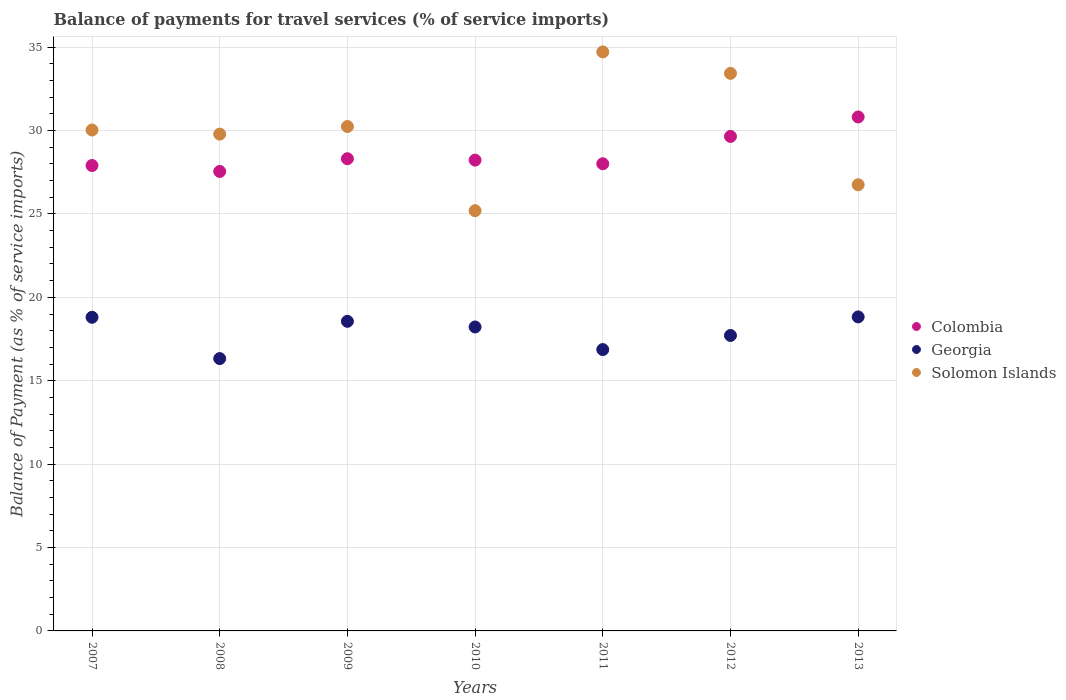How many different coloured dotlines are there?
Give a very brief answer. 3. What is the balance of payments for travel services in Colombia in 2009?
Make the answer very short. 28.31. Across all years, what is the maximum balance of payments for travel services in Colombia?
Ensure brevity in your answer.  30.82. Across all years, what is the minimum balance of payments for travel services in Colombia?
Ensure brevity in your answer.  27.55. In which year was the balance of payments for travel services in Solomon Islands minimum?
Make the answer very short. 2010. What is the total balance of payments for travel services in Georgia in the graph?
Provide a succinct answer. 125.33. What is the difference between the balance of payments for travel services in Georgia in 2011 and that in 2012?
Offer a terse response. -0.85. What is the difference between the balance of payments for travel services in Solomon Islands in 2007 and the balance of payments for travel services in Georgia in 2009?
Your response must be concise. 11.47. What is the average balance of payments for travel services in Colombia per year?
Give a very brief answer. 28.64. In the year 2010, what is the difference between the balance of payments for travel services in Colombia and balance of payments for travel services in Solomon Islands?
Your answer should be compact. 3.03. In how many years, is the balance of payments for travel services in Solomon Islands greater than 6 %?
Your response must be concise. 7. What is the ratio of the balance of payments for travel services in Solomon Islands in 2008 to that in 2010?
Your answer should be very brief. 1.18. Is the difference between the balance of payments for travel services in Colombia in 2008 and 2010 greater than the difference between the balance of payments for travel services in Solomon Islands in 2008 and 2010?
Keep it short and to the point. No. What is the difference between the highest and the second highest balance of payments for travel services in Solomon Islands?
Your answer should be compact. 1.29. What is the difference between the highest and the lowest balance of payments for travel services in Solomon Islands?
Provide a short and direct response. 9.52. Is the sum of the balance of payments for travel services in Georgia in 2009 and 2011 greater than the maximum balance of payments for travel services in Colombia across all years?
Your response must be concise. Yes. Is the balance of payments for travel services in Colombia strictly greater than the balance of payments for travel services in Georgia over the years?
Keep it short and to the point. Yes. Is the balance of payments for travel services in Georgia strictly less than the balance of payments for travel services in Solomon Islands over the years?
Ensure brevity in your answer.  Yes. Does the graph contain any zero values?
Your answer should be compact. No. What is the title of the graph?
Provide a succinct answer. Balance of payments for travel services (% of service imports). Does "Samoa" appear as one of the legend labels in the graph?
Offer a very short reply. No. What is the label or title of the Y-axis?
Keep it short and to the point. Balance of Payment (as % of service imports). What is the Balance of Payment (as % of service imports) in Colombia in 2007?
Keep it short and to the point. 27.91. What is the Balance of Payment (as % of service imports) of Georgia in 2007?
Offer a very short reply. 18.8. What is the Balance of Payment (as % of service imports) in Solomon Islands in 2007?
Provide a succinct answer. 30.03. What is the Balance of Payment (as % of service imports) of Colombia in 2008?
Make the answer very short. 27.55. What is the Balance of Payment (as % of service imports) of Georgia in 2008?
Your response must be concise. 16.33. What is the Balance of Payment (as % of service imports) of Solomon Islands in 2008?
Provide a short and direct response. 29.79. What is the Balance of Payment (as % of service imports) of Colombia in 2009?
Offer a terse response. 28.31. What is the Balance of Payment (as % of service imports) of Georgia in 2009?
Make the answer very short. 18.56. What is the Balance of Payment (as % of service imports) in Solomon Islands in 2009?
Make the answer very short. 30.24. What is the Balance of Payment (as % of service imports) of Colombia in 2010?
Your answer should be very brief. 28.23. What is the Balance of Payment (as % of service imports) of Georgia in 2010?
Your answer should be very brief. 18.22. What is the Balance of Payment (as % of service imports) in Solomon Islands in 2010?
Ensure brevity in your answer.  25.2. What is the Balance of Payment (as % of service imports) of Colombia in 2011?
Keep it short and to the point. 28.01. What is the Balance of Payment (as % of service imports) of Georgia in 2011?
Your response must be concise. 16.87. What is the Balance of Payment (as % of service imports) of Solomon Islands in 2011?
Offer a very short reply. 34.72. What is the Balance of Payment (as % of service imports) of Colombia in 2012?
Make the answer very short. 29.65. What is the Balance of Payment (as % of service imports) in Georgia in 2012?
Offer a very short reply. 17.71. What is the Balance of Payment (as % of service imports) of Solomon Islands in 2012?
Ensure brevity in your answer.  33.43. What is the Balance of Payment (as % of service imports) in Colombia in 2013?
Provide a succinct answer. 30.82. What is the Balance of Payment (as % of service imports) of Georgia in 2013?
Keep it short and to the point. 18.83. What is the Balance of Payment (as % of service imports) in Solomon Islands in 2013?
Keep it short and to the point. 26.75. Across all years, what is the maximum Balance of Payment (as % of service imports) in Colombia?
Make the answer very short. 30.82. Across all years, what is the maximum Balance of Payment (as % of service imports) of Georgia?
Provide a succinct answer. 18.83. Across all years, what is the maximum Balance of Payment (as % of service imports) in Solomon Islands?
Give a very brief answer. 34.72. Across all years, what is the minimum Balance of Payment (as % of service imports) of Colombia?
Your answer should be very brief. 27.55. Across all years, what is the minimum Balance of Payment (as % of service imports) of Georgia?
Provide a succinct answer. 16.33. Across all years, what is the minimum Balance of Payment (as % of service imports) of Solomon Islands?
Make the answer very short. 25.2. What is the total Balance of Payment (as % of service imports) of Colombia in the graph?
Offer a terse response. 200.47. What is the total Balance of Payment (as % of service imports) in Georgia in the graph?
Provide a short and direct response. 125.33. What is the total Balance of Payment (as % of service imports) of Solomon Islands in the graph?
Your answer should be very brief. 210.16. What is the difference between the Balance of Payment (as % of service imports) in Colombia in 2007 and that in 2008?
Your response must be concise. 0.36. What is the difference between the Balance of Payment (as % of service imports) of Georgia in 2007 and that in 2008?
Your answer should be very brief. 2.48. What is the difference between the Balance of Payment (as % of service imports) of Solomon Islands in 2007 and that in 2008?
Ensure brevity in your answer.  0.25. What is the difference between the Balance of Payment (as % of service imports) in Colombia in 2007 and that in 2009?
Provide a succinct answer. -0.41. What is the difference between the Balance of Payment (as % of service imports) in Georgia in 2007 and that in 2009?
Ensure brevity in your answer.  0.24. What is the difference between the Balance of Payment (as % of service imports) of Solomon Islands in 2007 and that in 2009?
Make the answer very short. -0.21. What is the difference between the Balance of Payment (as % of service imports) in Colombia in 2007 and that in 2010?
Keep it short and to the point. -0.32. What is the difference between the Balance of Payment (as % of service imports) of Georgia in 2007 and that in 2010?
Your answer should be very brief. 0.58. What is the difference between the Balance of Payment (as % of service imports) of Solomon Islands in 2007 and that in 2010?
Keep it short and to the point. 4.84. What is the difference between the Balance of Payment (as % of service imports) in Colombia in 2007 and that in 2011?
Give a very brief answer. -0.11. What is the difference between the Balance of Payment (as % of service imports) of Georgia in 2007 and that in 2011?
Offer a terse response. 1.94. What is the difference between the Balance of Payment (as % of service imports) in Solomon Islands in 2007 and that in 2011?
Provide a short and direct response. -4.68. What is the difference between the Balance of Payment (as % of service imports) of Colombia in 2007 and that in 2012?
Your response must be concise. -1.74. What is the difference between the Balance of Payment (as % of service imports) of Georgia in 2007 and that in 2012?
Ensure brevity in your answer.  1.09. What is the difference between the Balance of Payment (as % of service imports) of Solomon Islands in 2007 and that in 2012?
Ensure brevity in your answer.  -3.4. What is the difference between the Balance of Payment (as % of service imports) in Colombia in 2007 and that in 2013?
Offer a terse response. -2.91. What is the difference between the Balance of Payment (as % of service imports) in Georgia in 2007 and that in 2013?
Provide a short and direct response. -0.02. What is the difference between the Balance of Payment (as % of service imports) of Solomon Islands in 2007 and that in 2013?
Give a very brief answer. 3.28. What is the difference between the Balance of Payment (as % of service imports) of Colombia in 2008 and that in 2009?
Provide a short and direct response. -0.76. What is the difference between the Balance of Payment (as % of service imports) in Georgia in 2008 and that in 2009?
Provide a short and direct response. -2.23. What is the difference between the Balance of Payment (as % of service imports) of Solomon Islands in 2008 and that in 2009?
Your answer should be very brief. -0.46. What is the difference between the Balance of Payment (as % of service imports) of Colombia in 2008 and that in 2010?
Your answer should be compact. -0.68. What is the difference between the Balance of Payment (as % of service imports) in Georgia in 2008 and that in 2010?
Make the answer very short. -1.89. What is the difference between the Balance of Payment (as % of service imports) of Solomon Islands in 2008 and that in 2010?
Your answer should be compact. 4.59. What is the difference between the Balance of Payment (as % of service imports) in Colombia in 2008 and that in 2011?
Ensure brevity in your answer.  -0.46. What is the difference between the Balance of Payment (as % of service imports) of Georgia in 2008 and that in 2011?
Your answer should be very brief. -0.54. What is the difference between the Balance of Payment (as % of service imports) in Solomon Islands in 2008 and that in 2011?
Ensure brevity in your answer.  -4.93. What is the difference between the Balance of Payment (as % of service imports) of Colombia in 2008 and that in 2012?
Provide a succinct answer. -2.1. What is the difference between the Balance of Payment (as % of service imports) of Georgia in 2008 and that in 2012?
Offer a very short reply. -1.39. What is the difference between the Balance of Payment (as % of service imports) of Solomon Islands in 2008 and that in 2012?
Give a very brief answer. -3.64. What is the difference between the Balance of Payment (as % of service imports) of Colombia in 2008 and that in 2013?
Ensure brevity in your answer.  -3.27. What is the difference between the Balance of Payment (as % of service imports) in Georgia in 2008 and that in 2013?
Make the answer very short. -2.5. What is the difference between the Balance of Payment (as % of service imports) of Solomon Islands in 2008 and that in 2013?
Your response must be concise. 3.04. What is the difference between the Balance of Payment (as % of service imports) of Colombia in 2009 and that in 2010?
Give a very brief answer. 0.08. What is the difference between the Balance of Payment (as % of service imports) of Georgia in 2009 and that in 2010?
Keep it short and to the point. 0.34. What is the difference between the Balance of Payment (as % of service imports) of Solomon Islands in 2009 and that in 2010?
Give a very brief answer. 5.05. What is the difference between the Balance of Payment (as % of service imports) in Colombia in 2009 and that in 2011?
Keep it short and to the point. 0.3. What is the difference between the Balance of Payment (as % of service imports) of Georgia in 2009 and that in 2011?
Offer a very short reply. 1.69. What is the difference between the Balance of Payment (as % of service imports) in Solomon Islands in 2009 and that in 2011?
Make the answer very short. -4.47. What is the difference between the Balance of Payment (as % of service imports) of Colombia in 2009 and that in 2012?
Ensure brevity in your answer.  -1.34. What is the difference between the Balance of Payment (as % of service imports) in Georgia in 2009 and that in 2012?
Give a very brief answer. 0.85. What is the difference between the Balance of Payment (as % of service imports) in Solomon Islands in 2009 and that in 2012?
Offer a terse response. -3.19. What is the difference between the Balance of Payment (as % of service imports) in Colombia in 2009 and that in 2013?
Provide a succinct answer. -2.5. What is the difference between the Balance of Payment (as % of service imports) in Georgia in 2009 and that in 2013?
Give a very brief answer. -0.26. What is the difference between the Balance of Payment (as % of service imports) in Solomon Islands in 2009 and that in 2013?
Your answer should be compact. 3.49. What is the difference between the Balance of Payment (as % of service imports) in Colombia in 2010 and that in 2011?
Keep it short and to the point. 0.22. What is the difference between the Balance of Payment (as % of service imports) of Georgia in 2010 and that in 2011?
Offer a very short reply. 1.35. What is the difference between the Balance of Payment (as % of service imports) of Solomon Islands in 2010 and that in 2011?
Make the answer very short. -9.52. What is the difference between the Balance of Payment (as % of service imports) in Colombia in 2010 and that in 2012?
Keep it short and to the point. -1.42. What is the difference between the Balance of Payment (as % of service imports) of Georgia in 2010 and that in 2012?
Your response must be concise. 0.51. What is the difference between the Balance of Payment (as % of service imports) of Solomon Islands in 2010 and that in 2012?
Give a very brief answer. -8.23. What is the difference between the Balance of Payment (as % of service imports) of Colombia in 2010 and that in 2013?
Offer a very short reply. -2.59. What is the difference between the Balance of Payment (as % of service imports) in Georgia in 2010 and that in 2013?
Provide a succinct answer. -0.6. What is the difference between the Balance of Payment (as % of service imports) in Solomon Islands in 2010 and that in 2013?
Provide a short and direct response. -1.55. What is the difference between the Balance of Payment (as % of service imports) of Colombia in 2011 and that in 2012?
Make the answer very short. -1.64. What is the difference between the Balance of Payment (as % of service imports) of Georgia in 2011 and that in 2012?
Give a very brief answer. -0.85. What is the difference between the Balance of Payment (as % of service imports) in Solomon Islands in 2011 and that in 2012?
Your answer should be very brief. 1.29. What is the difference between the Balance of Payment (as % of service imports) of Colombia in 2011 and that in 2013?
Your answer should be compact. -2.8. What is the difference between the Balance of Payment (as % of service imports) in Georgia in 2011 and that in 2013?
Keep it short and to the point. -1.96. What is the difference between the Balance of Payment (as % of service imports) of Solomon Islands in 2011 and that in 2013?
Provide a short and direct response. 7.97. What is the difference between the Balance of Payment (as % of service imports) of Colombia in 2012 and that in 2013?
Your answer should be very brief. -1.17. What is the difference between the Balance of Payment (as % of service imports) in Georgia in 2012 and that in 2013?
Your answer should be very brief. -1.11. What is the difference between the Balance of Payment (as % of service imports) in Solomon Islands in 2012 and that in 2013?
Ensure brevity in your answer.  6.68. What is the difference between the Balance of Payment (as % of service imports) of Colombia in 2007 and the Balance of Payment (as % of service imports) of Georgia in 2008?
Make the answer very short. 11.58. What is the difference between the Balance of Payment (as % of service imports) in Colombia in 2007 and the Balance of Payment (as % of service imports) in Solomon Islands in 2008?
Provide a succinct answer. -1.88. What is the difference between the Balance of Payment (as % of service imports) of Georgia in 2007 and the Balance of Payment (as % of service imports) of Solomon Islands in 2008?
Provide a succinct answer. -10.98. What is the difference between the Balance of Payment (as % of service imports) in Colombia in 2007 and the Balance of Payment (as % of service imports) in Georgia in 2009?
Provide a succinct answer. 9.34. What is the difference between the Balance of Payment (as % of service imports) of Colombia in 2007 and the Balance of Payment (as % of service imports) of Solomon Islands in 2009?
Your response must be concise. -2.34. What is the difference between the Balance of Payment (as % of service imports) of Georgia in 2007 and the Balance of Payment (as % of service imports) of Solomon Islands in 2009?
Your answer should be very brief. -11.44. What is the difference between the Balance of Payment (as % of service imports) in Colombia in 2007 and the Balance of Payment (as % of service imports) in Georgia in 2010?
Your answer should be compact. 9.68. What is the difference between the Balance of Payment (as % of service imports) in Colombia in 2007 and the Balance of Payment (as % of service imports) in Solomon Islands in 2010?
Keep it short and to the point. 2.71. What is the difference between the Balance of Payment (as % of service imports) in Georgia in 2007 and the Balance of Payment (as % of service imports) in Solomon Islands in 2010?
Ensure brevity in your answer.  -6.39. What is the difference between the Balance of Payment (as % of service imports) of Colombia in 2007 and the Balance of Payment (as % of service imports) of Georgia in 2011?
Make the answer very short. 11.04. What is the difference between the Balance of Payment (as % of service imports) in Colombia in 2007 and the Balance of Payment (as % of service imports) in Solomon Islands in 2011?
Provide a short and direct response. -6.81. What is the difference between the Balance of Payment (as % of service imports) of Georgia in 2007 and the Balance of Payment (as % of service imports) of Solomon Islands in 2011?
Provide a short and direct response. -15.91. What is the difference between the Balance of Payment (as % of service imports) of Colombia in 2007 and the Balance of Payment (as % of service imports) of Georgia in 2012?
Provide a short and direct response. 10.19. What is the difference between the Balance of Payment (as % of service imports) in Colombia in 2007 and the Balance of Payment (as % of service imports) in Solomon Islands in 2012?
Your answer should be compact. -5.53. What is the difference between the Balance of Payment (as % of service imports) of Georgia in 2007 and the Balance of Payment (as % of service imports) of Solomon Islands in 2012?
Offer a terse response. -14.63. What is the difference between the Balance of Payment (as % of service imports) in Colombia in 2007 and the Balance of Payment (as % of service imports) in Georgia in 2013?
Your response must be concise. 9.08. What is the difference between the Balance of Payment (as % of service imports) of Colombia in 2007 and the Balance of Payment (as % of service imports) of Solomon Islands in 2013?
Make the answer very short. 1.16. What is the difference between the Balance of Payment (as % of service imports) in Georgia in 2007 and the Balance of Payment (as % of service imports) in Solomon Islands in 2013?
Give a very brief answer. -7.95. What is the difference between the Balance of Payment (as % of service imports) of Colombia in 2008 and the Balance of Payment (as % of service imports) of Georgia in 2009?
Your answer should be very brief. 8.99. What is the difference between the Balance of Payment (as % of service imports) of Colombia in 2008 and the Balance of Payment (as % of service imports) of Solomon Islands in 2009?
Provide a short and direct response. -2.69. What is the difference between the Balance of Payment (as % of service imports) in Georgia in 2008 and the Balance of Payment (as % of service imports) in Solomon Islands in 2009?
Provide a succinct answer. -13.91. What is the difference between the Balance of Payment (as % of service imports) in Colombia in 2008 and the Balance of Payment (as % of service imports) in Georgia in 2010?
Give a very brief answer. 9.33. What is the difference between the Balance of Payment (as % of service imports) of Colombia in 2008 and the Balance of Payment (as % of service imports) of Solomon Islands in 2010?
Provide a short and direct response. 2.35. What is the difference between the Balance of Payment (as % of service imports) in Georgia in 2008 and the Balance of Payment (as % of service imports) in Solomon Islands in 2010?
Your answer should be compact. -8.87. What is the difference between the Balance of Payment (as % of service imports) in Colombia in 2008 and the Balance of Payment (as % of service imports) in Georgia in 2011?
Your answer should be compact. 10.68. What is the difference between the Balance of Payment (as % of service imports) in Colombia in 2008 and the Balance of Payment (as % of service imports) in Solomon Islands in 2011?
Make the answer very short. -7.17. What is the difference between the Balance of Payment (as % of service imports) in Georgia in 2008 and the Balance of Payment (as % of service imports) in Solomon Islands in 2011?
Your answer should be very brief. -18.39. What is the difference between the Balance of Payment (as % of service imports) of Colombia in 2008 and the Balance of Payment (as % of service imports) of Georgia in 2012?
Give a very brief answer. 9.83. What is the difference between the Balance of Payment (as % of service imports) in Colombia in 2008 and the Balance of Payment (as % of service imports) in Solomon Islands in 2012?
Provide a succinct answer. -5.88. What is the difference between the Balance of Payment (as % of service imports) in Georgia in 2008 and the Balance of Payment (as % of service imports) in Solomon Islands in 2012?
Provide a short and direct response. -17.1. What is the difference between the Balance of Payment (as % of service imports) in Colombia in 2008 and the Balance of Payment (as % of service imports) in Georgia in 2013?
Keep it short and to the point. 8.72. What is the difference between the Balance of Payment (as % of service imports) of Colombia in 2008 and the Balance of Payment (as % of service imports) of Solomon Islands in 2013?
Ensure brevity in your answer.  0.8. What is the difference between the Balance of Payment (as % of service imports) in Georgia in 2008 and the Balance of Payment (as % of service imports) in Solomon Islands in 2013?
Provide a short and direct response. -10.42. What is the difference between the Balance of Payment (as % of service imports) in Colombia in 2009 and the Balance of Payment (as % of service imports) in Georgia in 2010?
Your response must be concise. 10.09. What is the difference between the Balance of Payment (as % of service imports) of Colombia in 2009 and the Balance of Payment (as % of service imports) of Solomon Islands in 2010?
Offer a terse response. 3.12. What is the difference between the Balance of Payment (as % of service imports) of Georgia in 2009 and the Balance of Payment (as % of service imports) of Solomon Islands in 2010?
Offer a terse response. -6.63. What is the difference between the Balance of Payment (as % of service imports) of Colombia in 2009 and the Balance of Payment (as % of service imports) of Georgia in 2011?
Offer a very short reply. 11.44. What is the difference between the Balance of Payment (as % of service imports) of Colombia in 2009 and the Balance of Payment (as % of service imports) of Solomon Islands in 2011?
Make the answer very short. -6.41. What is the difference between the Balance of Payment (as % of service imports) in Georgia in 2009 and the Balance of Payment (as % of service imports) in Solomon Islands in 2011?
Keep it short and to the point. -16.15. What is the difference between the Balance of Payment (as % of service imports) of Colombia in 2009 and the Balance of Payment (as % of service imports) of Georgia in 2012?
Your answer should be compact. 10.6. What is the difference between the Balance of Payment (as % of service imports) in Colombia in 2009 and the Balance of Payment (as % of service imports) in Solomon Islands in 2012?
Your answer should be very brief. -5.12. What is the difference between the Balance of Payment (as % of service imports) in Georgia in 2009 and the Balance of Payment (as % of service imports) in Solomon Islands in 2012?
Ensure brevity in your answer.  -14.87. What is the difference between the Balance of Payment (as % of service imports) in Colombia in 2009 and the Balance of Payment (as % of service imports) in Georgia in 2013?
Make the answer very short. 9.48. What is the difference between the Balance of Payment (as % of service imports) in Colombia in 2009 and the Balance of Payment (as % of service imports) in Solomon Islands in 2013?
Your answer should be compact. 1.56. What is the difference between the Balance of Payment (as % of service imports) of Georgia in 2009 and the Balance of Payment (as % of service imports) of Solomon Islands in 2013?
Offer a terse response. -8.19. What is the difference between the Balance of Payment (as % of service imports) of Colombia in 2010 and the Balance of Payment (as % of service imports) of Georgia in 2011?
Make the answer very short. 11.36. What is the difference between the Balance of Payment (as % of service imports) of Colombia in 2010 and the Balance of Payment (as % of service imports) of Solomon Islands in 2011?
Your answer should be compact. -6.49. What is the difference between the Balance of Payment (as % of service imports) of Georgia in 2010 and the Balance of Payment (as % of service imports) of Solomon Islands in 2011?
Give a very brief answer. -16.49. What is the difference between the Balance of Payment (as % of service imports) of Colombia in 2010 and the Balance of Payment (as % of service imports) of Georgia in 2012?
Ensure brevity in your answer.  10.51. What is the difference between the Balance of Payment (as % of service imports) in Colombia in 2010 and the Balance of Payment (as % of service imports) in Solomon Islands in 2012?
Provide a short and direct response. -5.2. What is the difference between the Balance of Payment (as % of service imports) of Georgia in 2010 and the Balance of Payment (as % of service imports) of Solomon Islands in 2012?
Give a very brief answer. -15.21. What is the difference between the Balance of Payment (as % of service imports) of Colombia in 2010 and the Balance of Payment (as % of service imports) of Georgia in 2013?
Your answer should be very brief. 9.4. What is the difference between the Balance of Payment (as % of service imports) of Colombia in 2010 and the Balance of Payment (as % of service imports) of Solomon Islands in 2013?
Give a very brief answer. 1.48. What is the difference between the Balance of Payment (as % of service imports) of Georgia in 2010 and the Balance of Payment (as % of service imports) of Solomon Islands in 2013?
Your answer should be very brief. -8.53. What is the difference between the Balance of Payment (as % of service imports) in Colombia in 2011 and the Balance of Payment (as % of service imports) in Georgia in 2012?
Keep it short and to the point. 10.3. What is the difference between the Balance of Payment (as % of service imports) in Colombia in 2011 and the Balance of Payment (as % of service imports) in Solomon Islands in 2012?
Provide a short and direct response. -5.42. What is the difference between the Balance of Payment (as % of service imports) in Georgia in 2011 and the Balance of Payment (as % of service imports) in Solomon Islands in 2012?
Your answer should be compact. -16.56. What is the difference between the Balance of Payment (as % of service imports) in Colombia in 2011 and the Balance of Payment (as % of service imports) in Georgia in 2013?
Provide a short and direct response. 9.18. What is the difference between the Balance of Payment (as % of service imports) of Colombia in 2011 and the Balance of Payment (as % of service imports) of Solomon Islands in 2013?
Ensure brevity in your answer.  1.26. What is the difference between the Balance of Payment (as % of service imports) in Georgia in 2011 and the Balance of Payment (as % of service imports) in Solomon Islands in 2013?
Your answer should be compact. -9.88. What is the difference between the Balance of Payment (as % of service imports) in Colombia in 2012 and the Balance of Payment (as % of service imports) in Georgia in 2013?
Provide a succinct answer. 10.82. What is the difference between the Balance of Payment (as % of service imports) of Colombia in 2012 and the Balance of Payment (as % of service imports) of Solomon Islands in 2013?
Your answer should be very brief. 2.9. What is the difference between the Balance of Payment (as % of service imports) of Georgia in 2012 and the Balance of Payment (as % of service imports) of Solomon Islands in 2013?
Provide a succinct answer. -9.04. What is the average Balance of Payment (as % of service imports) of Colombia per year?
Keep it short and to the point. 28.64. What is the average Balance of Payment (as % of service imports) in Georgia per year?
Give a very brief answer. 17.9. What is the average Balance of Payment (as % of service imports) in Solomon Islands per year?
Offer a very short reply. 30.02. In the year 2007, what is the difference between the Balance of Payment (as % of service imports) of Colombia and Balance of Payment (as % of service imports) of Georgia?
Provide a short and direct response. 9.1. In the year 2007, what is the difference between the Balance of Payment (as % of service imports) in Colombia and Balance of Payment (as % of service imports) in Solomon Islands?
Offer a very short reply. -2.13. In the year 2007, what is the difference between the Balance of Payment (as % of service imports) of Georgia and Balance of Payment (as % of service imports) of Solomon Islands?
Keep it short and to the point. -11.23. In the year 2008, what is the difference between the Balance of Payment (as % of service imports) of Colombia and Balance of Payment (as % of service imports) of Georgia?
Give a very brief answer. 11.22. In the year 2008, what is the difference between the Balance of Payment (as % of service imports) of Colombia and Balance of Payment (as % of service imports) of Solomon Islands?
Give a very brief answer. -2.24. In the year 2008, what is the difference between the Balance of Payment (as % of service imports) in Georgia and Balance of Payment (as % of service imports) in Solomon Islands?
Your answer should be compact. -13.46. In the year 2009, what is the difference between the Balance of Payment (as % of service imports) of Colombia and Balance of Payment (as % of service imports) of Georgia?
Provide a succinct answer. 9.75. In the year 2009, what is the difference between the Balance of Payment (as % of service imports) of Colombia and Balance of Payment (as % of service imports) of Solomon Islands?
Give a very brief answer. -1.93. In the year 2009, what is the difference between the Balance of Payment (as % of service imports) of Georgia and Balance of Payment (as % of service imports) of Solomon Islands?
Make the answer very short. -11.68. In the year 2010, what is the difference between the Balance of Payment (as % of service imports) in Colombia and Balance of Payment (as % of service imports) in Georgia?
Ensure brevity in your answer.  10.01. In the year 2010, what is the difference between the Balance of Payment (as % of service imports) in Colombia and Balance of Payment (as % of service imports) in Solomon Islands?
Offer a very short reply. 3.03. In the year 2010, what is the difference between the Balance of Payment (as % of service imports) in Georgia and Balance of Payment (as % of service imports) in Solomon Islands?
Offer a very short reply. -6.97. In the year 2011, what is the difference between the Balance of Payment (as % of service imports) in Colombia and Balance of Payment (as % of service imports) in Georgia?
Offer a terse response. 11.14. In the year 2011, what is the difference between the Balance of Payment (as % of service imports) of Colombia and Balance of Payment (as % of service imports) of Solomon Islands?
Give a very brief answer. -6.71. In the year 2011, what is the difference between the Balance of Payment (as % of service imports) in Georgia and Balance of Payment (as % of service imports) in Solomon Islands?
Give a very brief answer. -17.85. In the year 2012, what is the difference between the Balance of Payment (as % of service imports) of Colombia and Balance of Payment (as % of service imports) of Georgia?
Provide a short and direct response. 11.93. In the year 2012, what is the difference between the Balance of Payment (as % of service imports) in Colombia and Balance of Payment (as % of service imports) in Solomon Islands?
Your answer should be very brief. -3.78. In the year 2012, what is the difference between the Balance of Payment (as % of service imports) of Georgia and Balance of Payment (as % of service imports) of Solomon Islands?
Ensure brevity in your answer.  -15.72. In the year 2013, what is the difference between the Balance of Payment (as % of service imports) in Colombia and Balance of Payment (as % of service imports) in Georgia?
Provide a short and direct response. 11.99. In the year 2013, what is the difference between the Balance of Payment (as % of service imports) of Colombia and Balance of Payment (as % of service imports) of Solomon Islands?
Provide a short and direct response. 4.07. In the year 2013, what is the difference between the Balance of Payment (as % of service imports) in Georgia and Balance of Payment (as % of service imports) in Solomon Islands?
Keep it short and to the point. -7.92. What is the ratio of the Balance of Payment (as % of service imports) in Colombia in 2007 to that in 2008?
Offer a very short reply. 1.01. What is the ratio of the Balance of Payment (as % of service imports) in Georgia in 2007 to that in 2008?
Provide a succinct answer. 1.15. What is the ratio of the Balance of Payment (as % of service imports) of Solomon Islands in 2007 to that in 2008?
Offer a terse response. 1.01. What is the ratio of the Balance of Payment (as % of service imports) in Colombia in 2007 to that in 2009?
Your answer should be compact. 0.99. What is the ratio of the Balance of Payment (as % of service imports) in Solomon Islands in 2007 to that in 2009?
Your response must be concise. 0.99. What is the ratio of the Balance of Payment (as % of service imports) of Colombia in 2007 to that in 2010?
Make the answer very short. 0.99. What is the ratio of the Balance of Payment (as % of service imports) in Georgia in 2007 to that in 2010?
Give a very brief answer. 1.03. What is the ratio of the Balance of Payment (as % of service imports) in Solomon Islands in 2007 to that in 2010?
Provide a succinct answer. 1.19. What is the ratio of the Balance of Payment (as % of service imports) in Georgia in 2007 to that in 2011?
Your answer should be compact. 1.11. What is the ratio of the Balance of Payment (as % of service imports) in Solomon Islands in 2007 to that in 2011?
Offer a terse response. 0.87. What is the ratio of the Balance of Payment (as % of service imports) of Georgia in 2007 to that in 2012?
Your answer should be very brief. 1.06. What is the ratio of the Balance of Payment (as % of service imports) of Solomon Islands in 2007 to that in 2012?
Your answer should be very brief. 0.9. What is the ratio of the Balance of Payment (as % of service imports) in Colombia in 2007 to that in 2013?
Your response must be concise. 0.91. What is the ratio of the Balance of Payment (as % of service imports) of Solomon Islands in 2007 to that in 2013?
Ensure brevity in your answer.  1.12. What is the ratio of the Balance of Payment (as % of service imports) of Colombia in 2008 to that in 2009?
Give a very brief answer. 0.97. What is the ratio of the Balance of Payment (as % of service imports) of Georgia in 2008 to that in 2009?
Provide a short and direct response. 0.88. What is the ratio of the Balance of Payment (as % of service imports) in Solomon Islands in 2008 to that in 2009?
Provide a succinct answer. 0.98. What is the ratio of the Balance of Payment (as % of service imports) in Colombia in 2008 to that in 2010?
Offer a very short reply. 0.98. What is the ratio of the Balance of Payment (as % of service imports) in Georgia in 2008 to that in 2010?
Provide a short and direct response. 0.9. What is the ratio of the Balance of Payment (as % of service imports) of Solomon Islands in 2008 to that in 2010?
Offer a very short reply. 1.18. What is the ratio of the Balance of Payment (as % of service imports) in Colombia in 2008 to that in 2011?
Ensure brevity in your answer.  0.98. What is the ratio of the Balance of Payment (as % of service imports) in Solomon Islands in 2008 to that in 2011?
Provide a succinct answer. 0.86. What is the ratio of the Balance of Payment (as % of service imports) of Colombia in 2008 to that in 2012?
Provide a short and direct response. 0.93. What is the ratio of the Balance of Payment (as % of service imports) in Georgia in 2008 to that in 2012?
Provide a short and direct response. 0.92. What is the ratio of the Balance of Payment (as % of service imports) in Solomon Islands in 2008 to that in 2012?
Your response must be concise. 0.89. What is the ratio of the Balance of Payment (as % of service imports) of Colombia in 2008 to that in 2013?
Offer a very short reply. 0.89. What is the ratio of the Balance of Payment (as % of service imports) in Georgia in 2008 to that in 2013?
Keep it short and to the point. 0.87. What is the ratio of the Balance of Payment (as % of service imports) in Solomon Islands in 2008 to that in 2013?
Provide a succinct answer. 1.11. What is the ratio of the Balance of Payment (as % of service imports) of Colombia in 2009 to that in 2010?
Ensure brevity in your answer.  1. What is the ratio of the Balance of Payment (as % of service imports) of Georgia in 2009 to that in 2010?
Make the answer very short. 1.02. What is the ratio of the Balance of Payment (as % of service imports) in Solomon Islands in 2009 to that in 2010?
Give a very brief answer. 1.2. What is the ratio of the Balance of Payment (as % of service imports) of Colombia in 2009 to that in 2011?
Offer a terse response. 1.01. What is the ratio of the Balance of Payment (as % of service imports) of Georgia in 2009 to that in 2011?
Your answer should be compact. 1.1. What is the ratio of the Balance of Payment (as % of service imports) in Solomon Islands in 2009 to that in 2011?
Offer a very short reply. 0.87. What is the ratio of the Balance of Payment (as % of service imports) of Colombia in 2009 to that in 2012?
Provide a short and direct response. 0.95. What is the ratio of the Balance of Payment (as % of service imports) in Georgia in 2009 to that in 2012?
Offer a very short reply. 1.05. What is the ratio of the Balance of Payment (as % of service imports) in Solomon Islands in 2009 to that in 2012?
Your answer should be very brief. 0.9. What is the ratio of the Balance of Payment (as % of service imports) of Colombia in 2009 to that in 2013?
Provide a succinct answer. 0.92. What is the ratio of the Balance of Payment (as % of service imports) in Solomon Islands in 2009 to that in 2013?
Offer a terse response. 1.13. What is the ratio of the Balance of Payment (as % of service imports) of Colombia in 2010 to that in 2011?
Provide a short and direct response. 1.01. What is the ratio of the Balance of Payment (as % of service imports) of Georgia in 2010 to that in 2011?
Keep it short and to the point. 1.08. What is the ratio of the Balance of Payment (as % of service imports) in Solomon Islands in 2010 to that in 2011?
Provide a succinct answer. 0.73. What is the ratio of the Balance of Payment (as % of service imports) of Colombia in 2010 to that in 2012?
Provide a short and direct response. 0.95. What is the ratio of the Balance of Payment (as % of service imports) in Georgia in 2010 to that in 2012?
Make the answer very short. 1.03. What is the ratio of the Balance of Payment (as % of service imports) of Solomon Islands in 2010 to that in 2012?
Give a very brief answer. 0.75. What is the ratio of the Balance of Payment (as % of service imports) of Colombia in 2010 to that in 2013?
Make the answer very short. 0.92. What is the ratio of the Balance of Payment (as % of service imports) in Georgia in 2010 to that in 2013?
Give a very brief answer. 0.97. What is the ratio of the Balance of Payment (as % of service imports) in Solomon Islands in 2010 to that in 2013?
Keep it short and to the point. 0.94. What is the ratio of the Balance of Payment (as % of service imports) in Colombia in 2011 to that in 2012?
Make the answer very short. 0.94. What is the ratio of the Balance of Payment (as % of service imports) of Georgia in 2011 to that in 2012?
Make the answer very short. 0.95. What is the ratio of the Balance of Payment (as % of service imports) in Solomon Islands in 2011 to that in 2012?
Offer a terse response. 1.04. What is the ratio of the Balance of Payment (as % of service imports) in Colombia in 2011 to that in 2013?
Provide a succinct answer. 0.91. What is the ratio of the Balance of Payment (as % of service imports) of Georgia in 2011 to that in 2013?
Keep it short and to the point. 0.9. What is the ratio of the Balance of Payment (as % of service imports) of Solomon Islands in 2011 to that in 2013?
Your answer should be very brief. 1.3. What is the ratio of the Balance of Payment (as % of service imports) in Colombia in 2012 to that in 2013?
Keep it short and to the point. 0.96. What is the ratio of the Balance of Payment (as % of service imports) of Georgia in 2012 to that in 2013?
Your answer should be very brief. 0.94. What is the ratio of the Balance of Payment (as % of service imports) in Solomon Islands in 2012 to that in 2013?
Ensure brevity in your answer.  1.25. What is the difference between the highest and the second highest Balance of Payment (as % of service imports) of Colombia?
Ensure brevity in your answer.  1.17. What is the difference between the highest and the second highest Balance of Payment (as % of service imports) of Georgia?
Keep it short and to the point. 0.02. What is the difference between the highest and the second highest Balance of Payment (as % of service imports) in Solomon Islands?
Your response must be concise. 1.29. What is the difference between the highest and the lowest Balance of Payment (as % of service imports) of Colombia?
Offer a very short reply. 3.27. What is the difference between the highest and the lowest Balance of Payment (as % of service imports) in Georgia?
Offer a terse response. 2.5. What is the difference between the highest and the lowest Balance of Payment (as % of service imports) in Solomon Islands?
Your answer should be very brief. 9.52. 